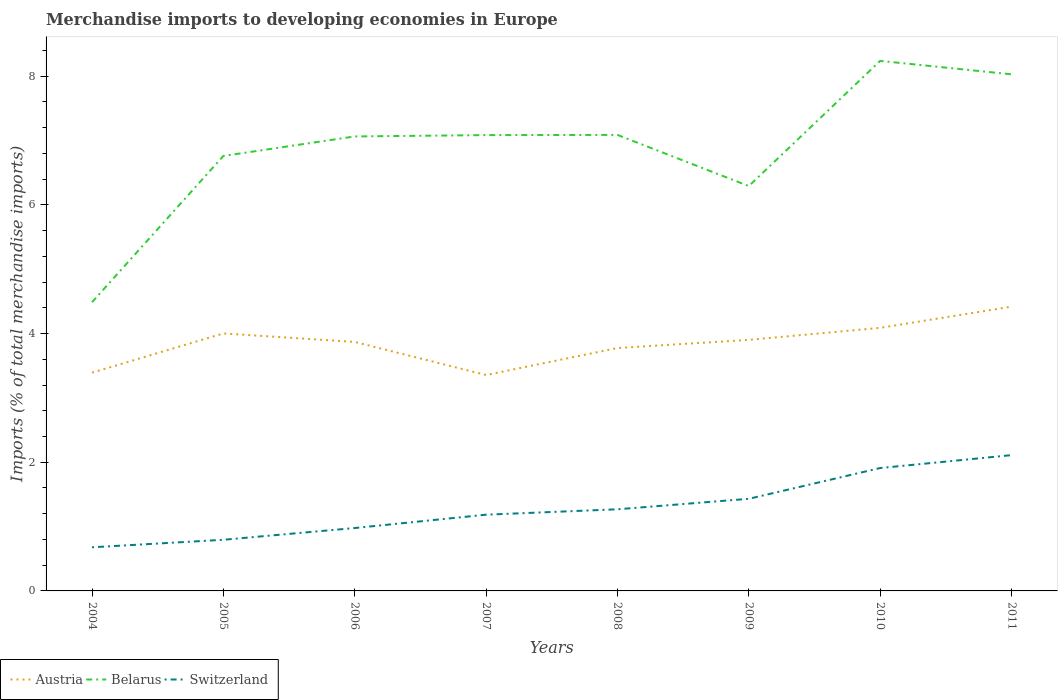Does the line corresponding to Switzerland intersect with the line corresponding to Austria?
Make the answer very short. No. Is the number of lines equal to the number of legend labels?
Your answer should be very brief. Yes. Across all years, what is the maximum percentage total merchandise imports in Austria?
Your response must be concise. 3.36. In which year was the percentage total merchandise imports in Austria maximum?
Offer a very short reply. 2007. What is the total percentage total merchandise imports in Austria in the graph?
Your response must be concise. -0.31. What is the difference between the highest and the second highest percentage total merchandise imports in Switzerland?
Offer a terse response. 1.43. Is the percentage total merchandise imports in Austria strictly greater than the percentage total merchandise imports in Switzerland over the years?
Your answer should be compact. No. How many lines are there?
Ensure brevity in your answer.  3. Does the graph contain grids?
Give a very brief answer. No. Where does the legend appear in the graph?
Your answer should be very brief. Bottom left. What is the title of the graph?
Provide a short and direct response. Merchandise imports to developing economies in Europe. What is the label or title of the X-axis?
Keep it short and to the point. Years. What is the label or title of the Y-axis?
Your answer should be very brief. Imports (% of total merchandise imports). What is the Imports (% of total merchandise imports) in Austria in 2004?
Ensure brevity in your answer.  3.39. What is the Imports (% of total merchandise imports) in Belarus in 2004?
Your answer should be compact. 4.49. What is the Imports (% of total merchandise imports) of Switzerland in 2004?
Ensure brevity in your answer.  0.68. What is the Imports (% of total merchandise imports) in Austria in 2005?
Offer a very short reply. 4. What is the Imports (% of total merchandise imports) of Belarus in 2005?
Your response must be concise. 6.76. What is the Imports (% of total merchandise imports) of Switzerland in 2005?
Your response must be concise. 0.79. What is the Imports (% of total merchandise imports) of Austria in 2006?
Make the answer very short. 3.87. What is the Imports (% of total merchandise imports) of Belarus in 2006?
Make the answer very short. 7.06. What is the Imports (% of total merchandise imports) in Switzerland in 2006?
Make the answer very short. 0.98. What is the Imports (% of total merchandise imports) in Austria in 2007?
Provide a succinct answer. 3.36. What is the Imports (% of total merchandise imports) in Belarus in 2007?
Provide a succinct answer. 7.08. What is the Imports (% of total merchandise imports) in Switzerland in 2007?
Provide a short and direct response. 1.18. What is the Imports (% of total merchandise imports) of Austria in 2008?
Provide a succinct answer. 3.77. What is the Imports (% of total merchandise imports) in Belarus in 2008?
Keep it short and to the point. 7.09. What is the Imports (% of total merchandise imports) of Switzerland in 2008?
Your answer should be compact. 1.27. What is the Imports (% of total merchandise imports) of Austria in 2009?
Ensure brevity in your answer.  3.9. What is the Imports (% of total merchandise imports) of Belarus in 2009?
Offer a very short reply. 6.29. What is the Imports (% of total merchandise imports) in Switzerland in 2009?
Provide a succinct answer. 1.43. What is the Imports (% of total merchandise imports) of Austria in 2010?
Offer a very short reply. 4.09. What is the Imports (% of total merchandise imports) of Belarus in 2010?
Offer a very short reply. 8.24. What is the Imports (% of total merchandise imports) of Switzerland in 2010?
Make the answer very short. 1.91. What is the Imports (% of total merchandise imports) in Austria in 2011?
Provide a succinct answer. 4.42. What is the Imports (% of total merchandise imports) of Belarus in 2011?
Your answer should be very brief. 8.03. What is the Imports (% of total merchandise imports) of Switzerland in 2011?
Provide a succinct answer. 2.11. Across all years, what is the maximum Imports (% of total merchandise imports) of Austria?
Ensure brevity in your answer.  4.42. Across all years, what is the maximum Imports (% of total merchandise imports) of Belarus?
Your answer should be very brief. 8.24. Across all years, what is the maximum Imports (% of total merchandise imports) in Switzerland?
Keep it short and to the point. 2.11. Across all years, what is the minimum Imports (% of total merchandise imports) in Austria?
Your response must be concise. 3.36. Across all years, what is the minimum Imports (% of total merchandise imports) in Belarus?
Provide a succinct answer. 4.49. Across all years, what is the minimum Imports (% of total merchandise imports) in Switzerland?
Keep it short and to the point. 0.68. What is the total Imports (% of total merchandise imports) of Austria in the graph?
Your answer should be very brief. 30.8. What is the total Imports (% of total merchandise imports) of Belarus in the graph?
Your answer should be very brief. 55.04. What is the total Imports (% of total merchandise imports) of Switzerland in the graph?
Offer a terse response. 10.36. What is the difference between the Imports (% of total merchandise imports) of Austria in 2004 and that in 2005?
Offer a terse response. -0.61. What is the difference between the Imports (% of total merchandise imports) in Belarus in 2004 and that in 2005?
Make the answer very short. -2.27. What is the difference between the Imports (% of total merchandise imports) in Switzerland in 2004 and that in 2005?
Ensure brevity in your answer.  -0.12. What is the difference between the Imports (% of total merchandise imports) of Austria in 2004 and that in 2006?
Your response must be concise. -0.48. What is the difference between the Imports (% of total merchandise imports) of Belarus in 2004 and that in 2006?
Offer a very short reply. -2.58. What is the difference between the Imports (% of total merchandise imports) of Switzerland in 2004 and that in 2006?
Offer a very short reply. -0.3. What is the difference between the Imports (% of total merchandise imports) in Austria in 2004 and that in 2007?
Your response must be concise. 0.04. What is the difference between the Imports (% of total merchandise imports) in Belarus in 2004 and that in 2007?
Offer a very short reply. -2.6. What is the difference between the Imports (% of total merchandise imports) in Switzerland in 2004 and that in 2007?
Your answer should be compact. -0.51. What is the difference between the Imports (% of total merchandise imports) of Austria in 2004 and that in 2008?
Provide a succinct answer. -0.38. What is the difference between the Imports (% of total merchandise imports) in Belarus in 2004 and that in 2008?
Ensure brevity in your answer.  -2.6. What is the difference between the Imports (% of total merchandise imports) of Switzerland in 2004 and that in 2008?
Provide a succinct answer. -0.59. What is the difference between the Imports (% of total merchandise imports) of Austria in 2004 and that in 2009?
Offer a terse response. -0.51. What is the difference between the Imports (% of total merchandise imports) in Belarus in 2004 and that in 2009?
Provide a succinct answer. -1.8. What is the difference between the Imports (% of total merchandise imports) of Switzerland in 2004 and that in 2009?
Provide a short and direct response. -0.75. What is the difference between the Imports (% of total merchandise imports) in Austria in 2004 and that in 2010?
Keep it short and to the point. -0.7. What is the difference between the Imports (% of total merchandise imports) in Belarus in 2004 and that in 2010?
Give a very brief answer. -3.75. What is the difference between the Imports (% of total merchandise imports) in Switzerland in 2004 and that in 2010?
Your answer should be compact. -1.23. What is the difference between the Imports (% of total merchandise imports) of Austria in 2004 and that in 2011?
Ensure brevity in your answer.  -1.03. What is the difference between the Imports (% of total merchandise imports) in Belarus in 2004 and that in 2011?
Your response must be concise. -3.54. What is the difference between the Imports (% of total merchandise imports) in Switzerland in 2004 and that in 2011?
Offer a very short reply. -1.43. What is the difference between the Imports (% of total merchandise imports) in Austria in 2005 and that in 2006?
Ensure brevity in your answer.  0.13. What is the difference between the Imports (% of total merchandise imports) in Belarus in 2005 and that in 2006?
Offer a very short reply. -0.3. What is the difference between the Imports (% of total merchandise imports) of Switzerland in 2005 and that in 2006?
Provide a succinct answer. -0.18. What is the difference between the Imports (% of total merchandise imports) in Austria in 2005 and that in 2007?
Ensure brevity in your answer.  0.65. What is the difference between the Imports (% of total merchandise imports) of Belarus in 2005 and that in 2007?
Provide a short and direct response. -0.32. What is the difference between the Imports (% of total merchandise imports) of Switzerland in 2005 and that in 2007?
Offer a terse response. -0.39. What is the difference between the Imports (% of total merchandise imports) in Austria in 2005 and that in 2008?
Ensure brevity in your answer.  0.23. What is the difference between the Imports (% of total merchandise imports) in Belarus in 2005 and that in 2008?
Ensure brevity in your answer.  -0.33. What is the difference between the Imports (% of total merchandise imports) in Switzerland in 2005 and that in 2008?
Keep it short and to the point. -0.47. What is the difference between the Imports (% of total merchandise imports) of Austria in 2005 and that in 2009?
Your response must be concise. 0.1. What is the difference between the Imports (% of total merchandise imports) in Belarus in 2005 and that in 2009?
Give a very brief answer. 0.47. What is the difference between the Imports (% of total merchandise imports) of Switzerland in 2005 and that in 2009?
Your response must be concise. -0.64. What is the difference between the Imports (% of total merchandise imports) in Austria in 2005 and that in 2010?
Provide a succinct answer. -0.09. What is the difference between the Imports (% of total merchandise imports) of Belarus in 2005 and that in 2010?
Ensure brevity in your answer.  -1.48. What is the difference between the Imports (% of total merchandise imports) of Switzerland in 2005 and that in 2010?
Provide a succinct answer. -1.11. What is the difference between the Imports (% of total merchandise imports) in Austria in 2005 and that in 2011?
Your response must be concise. -0.42. What is the difference between the Imports (% of total merchandise imports) of Belarus in 2005 and that in 2011?
Offer a terse response. -1.27. What is the difference between the Imports (% of total merchandise imports) of Switzerland in 2005 and that in 2011?
Provide a succinct answer. -1.32. What is the difference between the Imports (% of total merchandise imports) of Austria in 2006 and that in 2007?
Your answer should be very brief. 0.51. What is the difference between the Imports (% of total merchandise imports) in Belarus in 2006 and that in 2007?
Your answer should be very brief. -0.02. What is the difference between the Imports (% of total merchandise imports) of Switzerland in 2006 and that in 2007?
Your answer should be compact. -0.21. What is the difference between the Imports (% of total merchandise imports) in Austria in 2006 and that in 2008?
Your answer should be compact. 0.09. What is the difference between the Imports (% of total merchandise imports) of Belarus in 2006 and that in 2008?
Your answer should be very brief. -0.02. What is the difference between the Imports (% of total merchandise imports) of Switzerland in 2006 and that in 2008?
Your response must be concise. -0.29. What is the difference between the Imports (% of total merchandise imports) in Austria in 2006 and that in 2009?
Provide a short and direct response. -0.03. What is the difference between the Imports (% of total merchandise imports) in Belarus in 2006 and that in 2009?
Provide a succinct answer. 0.77. What is the difference between the Imports (% of total merchandise imports) in Switzerland in 2006 and that in 2009?
Offer a very short reply. -0.45. What is the difference between the Imports (% of total merchandise imports) of Austria in 2006 and that in 2010?
Give a very brief answer. -0.22. What is the difference between the Imports (% of total merchandise imports) in Belarus in 2006 and that in 2010?
Your answer should be compact. -1.17. What is the difference between the Imports (% of total merchandise imports) of Switzerland in 2006 and that in 2010?
Give a very brief answer. -0.93. What is the difference between the Imports (% of total merchandise imports) of Austria in 2006 and that in 2011?
Provide a short and direct response. -0.55. What is the difference between the Imports (% of total merchandise imports) of Belarus in 2006 and that in 2011?
Give a very brief answer. -0.97. What is the difference between the Imports (% of total merchandise imports) of Switzerland in 2006 and that in 2011?
Make the answer very short. -1.13. What is the difference between the Imports (% of total merchandise imports) of Austria in 2007 and that in 2008?
Offer a terse response. -0.42. What is the difference between the Imports (% of total merchandise imports) in Belarus in 2007 and that in 2008?
Keep it short and to the point. -0. What is the difference between the Imports (% of total merchandise imports) of Switzerland in 2007 and that in 2008?
Offer a terse response. -0.08. What is the difference between the Imports (% of total merchandise imports) in Austria in 2007 and that in 2009?
Your answer should be very brief. -0.55. What is the difference between the Imports (% of total merchandise imports) in Belarus in 2007 and that in 2009?
Provide a short and direct response. 0.79. What is the difference between the Imports (% of total merchandise imports) of Switzerland in 2007 and that in 2009?
Offer a very short reply. -0.25. What is the difference between the Imports (% of total merchandise imports) of Austria in 2007 and that in 2010?
Your answer should be compact. -0.73. What is the difference between the Imports (% of total merchandise imports) in Belarus in 2007 and that in 2010?
Offer a terse response. -1.15. What is the difference between the Imports (% of total merchandise imports) in Switzerland in 2007 and that in 2010?
Offer a very short reply. -0.72. What is the difference between the Imports (% of total merchandise imports) of Austria in 2007 and that in 2011?
Offer a very short reply. -1.06. What is the difference between the Imports (% of total merchandise imports) of Belarus in 2007 and that in 2011?
Your answer should be very brief. -0.94. What is the difference between the Imports (% of total merchandise imports) of Switzerland in 2007 and that in 2011?
Provide a short and direct response. -0.93. What is the difference between the Imports (% of total merchandise imports) of Austria in 2008 and that in 2009?
Keep it short and to the point. -0.13. What is the difference between the Imports (% of total merchandise imports) in Belarus in 2008 and that in 2009?
Offer a very short reply. 0.8. What is the difference between the Imports (% of total merchandise imports) of Switzerland in 2008 and that in 2009?
Provide a short and direct response. -0.16. What is the difference between the Imports (% of total merchandise imports) in Austria in 2008 and that in 2010?
Ensure brevity in your answer.  -0.31. What is the difference between the Imports (% of total merchandise imports) in Belarus in 2008 and that in 2010?
Offer a terse response. -1.15. What is the difference between the Imports (% of total merchandise imports) in Switzerland in 2008 and that in 2010?
Your response must be concise. -0.64. What is the difference between the Imports (% of total merchandise imports) in Austria in 2008 and that in 2011?
Provide a short and direct response. -0.64. What is the difference between the Imports (% of total merchandise imports) in Belarus in 2008 and that in 2011?
Provide a succinct answer. -0.94. What is the difference between the Imports (% of total merchandise imports) in Switzerland in 2008 and that in 2011?
Your answer should be compact. -0.84. What is the difference between the Imports (% of total merchandise imports) in Austria in 2009 and that in 2010?
Give a very brief answer. -0.19. What is the difference between the Imports (% of total merchandise imports) in Belarus in 2009 and that in 2010?
Your answer should be compact. -1.95. What is the difference between the Imports (% of total merchandise imports) of Switzerland in 2009 and that in 2010?
Offer a terse response. -0.48. What is the difference between the Imports (% of total merchandise imports) of Austria in 2009 and that in 2011?
Provide a succinct answer. -0.52. What is the difference between the Imports (% of total merchandise imports) of Belarus in 2009 and that in 2011?
Make the answer very short. -1.74. What is the difference between the Imports (% of total merchandise imports) of Switzerland in 2009 and that in 2011?
Make the answer very short. -0.68. What is the difference between the Imports (% of total merchandise imports) in Austria in 2010 and that in 2011?
Offer a very short reply. -0.33. What is the difference between the Imports (% of total merchandise imports) in Belarus in 2010 and that in 2011?
Provide a succinct answer. 0.21. What is the difference between the Imports (% of total merchandise imports) of Switzerland in 2010 and that in 2011?
Make the answer very short. -0.2. What is the difference between the Imports (% of total merchandise imports) in Austria in 2004 and the Imports (% of total merchandise imports) in Belarus in 2005?
Offer a terse response. -3.37. What is the difference between the Imports (% of total merchandise imports) in Austria in 2004 and the Imports (% of total merchandise imports) in Switzerland in 2005?
Offer a very short reply. 2.6. What is the difference between the Imports (% of total merchandise imports) of Belarus in 2004 and the Imports (% of total merchandise imports) of Switzerland in 2005?
Your response must be concise. 3.69. What is the difference between the Imports (% of total merchandise imports) in Austria in 2004 and the Imports (% of total merchandise imports) in Belarus in 2006?
Your answer should be very brief. -3.67. What is the difference between the Imports (% of total merchandise imports) of Austria in 2004 and the Imports (% of total merchandise imports) of Switzerland in 2006?
Your answer should be compact. 2.41. What is the difference between the Imports (% of total merchandise imports) of Belarus in 2004 and the Imports (% of total merchandise imports) of Switzerland in 2006?
Keep it short and to the point. 3.51. What is the difference between the Imports (% of total merchandise imports) in Austria in 2004 and the Imports (% of total merchandise imports) in Belarus in 2007?
Keep it short and to the point. -3.69. What is the difference between the Imports (% of total merchandise imports) of Austria in 2004 and the Imports (% of total merchandise imports) of Switzerland in 2007?
Make the answer very short. 2.21. What is the difference between the Imports (% of total merchandise imports) of Belarus in 2004 and the Imports (% of total merchandise imports) of Switzerland in 2007?
Keep it short and to the point. 3.3. What is the difference between the Imports (% of total merchandise imports) in Austria in 2004 and the Imports (% of total merchandise imports) in Belarus in 2008?
Provide a succinct answer. -3.69. What is the difference between the Imports (% of total merchandise imports) of Austria in 2004 and the Imports (% of total merchandise imports) of Switzerland in 2008?
Provide a short and direct response. 2.12. What is the difference between the Imports (% of total merchandise imports) of Belarus in 2004 and the Imports (% of total merchandise imports) of Switzerland in 2008?
Your response must be concise. 3.22. What is the difference between the Imports (% of total merchandise imports) in Austria in 2004 and the Imports (% of total merchandise imports) in Belarus in 2009?
Make the answer very short. -2.9. What is the difference between the Imports (% of total merchandise imports) in Austria in 2004 and the Imports (% of total merchandise imports) in Switzerland in 2009?
Your answer should be very brief. 1.96. What is the difference between the Imports (% of total merchandise imports) of Belarus in 2004 and the Imports (% of total merchandise imports) of Switzerland in 2009?
Keep it short and to the point. 3.05. What is the difference between the Imports (% of total merchandise imports) of Austria in 2004 and the Imports (% of total merchandise imports) of Belarus in 2010?
Your answer should be very brief. -4.85. What is the difference between the Imports (% of total merchandise imports) of Austria in 2004 and the Imports (% of total merchandise imports) of Switzerland in 2010?
Your response must be concise. 1.48. What is the difference between the Imports (% of total merchandise imports) in Belarus in 2004 and the Imports (% of total merchandise imports) in Switzerland in 2010?
Your answer should be very brief. 2.58. What is the difference between the Imports (% of total merchandise imports) in Austria in 2004 and the Imports (% of total merchandise imports) in Belarus in 2011?
Give a very brief answer. -4.64. What is the difference between the Imports (% of total merchandise imports) in Austria in 2004 and the Imports (% of total merchandise imports) in Switzerland in 2011?
Ensure brevity in your answer.  1.28. What is the difference between the Imports (% of total merchandise imports) of Belarus in 2004 and the Imports (% of total merchandise imports) of Switzerland in 2011?
Provide a succinct answer. 2.38. What is the difference between the Imports (% of total merchandise imports) in Austria in 2005 and the Imports (% of total merchandise imports) in Belarus in 2006?
Ensure brevity in your answer.  -3.06. What is the difference between the Imports (% of total merchandise imports) of Austria in 2005 and the Imports (% of total merchandise imports) of Switzerland in 2006?
Provide a succinct answer. 3.02. What is the difference between the Imports (% of total merchandise imports) in Belarus in 2005 and the Imports (% of total merchandise imports) in Switzerland in 2006?
Offer a terse response. 5.78. What is the difference between the Imports (% of total merchandise imports) of Austria in 2005 and the Imports (% of total merchandise imports) of Belarus in 2007?
Provide a succinct answer. -3.08. What is the difference between the Imports (% of total merchandise imports) of Austria in 2005 and the Imports (% of total merchandise imports) of Switzerland in 2007?
Your answer should be very brief. 2.82. What is the difference between the Imports (% of total merchandise imports) of Belarus in 2005 and the Imports (% of total merchandise imports) of Switzerland in 2007?
Make the answer very short. 5.58. What is the difference between the Imports (% of total merchandise imports) in Austria in 2005 and the Imports (% of total merchandise imports) in Belarus in 2008?
Ensure brevity in your answer.  -3.09. What is the difference between the Imports (% of total merchandise imports) in Austria in 2005 and the Imports (% of total merchandise imports) in Switzerland in 2008?
Your response must be concise. 2.73. What is the difference between the Imports (% of total merchandise imports) of Belarus in 2005 and the Imports (% of total merchandise imports) of Switzerland in 2008?
Ensure brevity in your answer.  5.49. What is the difference between the Imports (% of total merchandise imports) of Austria in 2005 and the Imports (% of total merchandise imports) of Belarus in 2009?
Give a very brief answer. -2.29. What is the difference between the Imports (% of total merchandise imports) in Austria in 2005 and the Imports (% of total merchandise imports) in Switzerland in 2009?
Make the answer very short. 2.57. What is the difference between the Imports (% of total merchandise imports) in Belarus in 2005 and the Imports (% of total merchandise imports) in Switzerland in 2009?
Give a very brief answer. 5.33. What is the difference between the Imports (% of total merchandise imports) of Austria in 2005 and the Imports (% of total merchandise imports) of Belarus in 2010?
Provide a succinct answer. -4.24. What is the difference between the Imports (% of total merchandise imports) of Austria in 2005 and the Imports (% of total merchandise imports) of Switzerland in 2010?
Give a very brief answer. 2.09. What is the difference between the Imports (% of total merchandise imports) of Belarus in 2005 and the Imports (% of total merchandise imports) of Switzerland in 2010?
Provide a short and direct response. 4.85. What is the difference between the Imports (% of total merchandise imports) in Austria in 2005 and the Imports (% of total merchandise imports) in Belarus in 2011?
Ensure brevity in your answer.  -4.03. What is the difference between the Imports (% of total merchandise imports) in Austria in 2005 and the Imports (% of total merchandise imports) in Switzerland in 2011?
Keep it short and to the point. 1.89. What is the difference between the Imports (% of total merchandise imports) of Belarus in 2005 and the Imports (% of total merchandise imports) of Switzerland in 2011?
Your answer should be compact. 4.65. What is the difference between the Imports (% of total merchandise imports) of Austria in 2006 and the Imports (% of total merchandise imports) of Belarus in 2007?
Your response must be concise. -3.21. What is the difference between the Imports (% of total merchandise imports) of Austria in 2006 and the Imports (% of total merchandise imports) of Switzerland in 2007?
Your answer should be very brief. 2.68. What is the difference between the Imports (% of total merchandise imports) of Belarus in 2006 and the Imports (% of total merchandise imports) of Switzerland in 2007?
Give a very brief answer. 5.88. What is the difference between the Imports (% of total merchandise imports) in Austria in 2006 and the Imports (% of total merchandise imports) in Belarus in 2008?
Your answer should be very brief. -3.22. What is the difference between the Imports (% of total merchandise imports) in Austria in 2006 and the Imports (% of total merchandise imports) in Switzerland in 2008?
Offer a very short reply. 2.6. What is the difference between the Imports (% of total merchandise imports) in Belarus in 2006 and the Imports (% of total merchandise imports) in Switzerland in 2008?
Your response must be concise. 5.79. What is the difference between the Imports (% of total merchandise imports) of Austria in 2006 and the Imports (% of total merchandise imports) of Belarus in 2009?
Provide a succinct answer. -2.42. What is the difference between the Imports (% of total merchandise imports) of Austria in 2006 and the Imports (% of total merchandise imports) of Switzerland in 2009?
Offer a terse response. 2.44. What is the difference between the Imports (% of total merchandise imports) of Belarus in 2006 and the Imports (% of total merchandise imports) of Switzerland in 2009?
Offer a very short reply. 5.63. What is the difference between the Imports (% of total merchandise imports) in Austria in 2006 and the Imports (% of total merchandise imports) in Belarus in 2010?
Your response must be concise. -4.37. What is the difference between the Imports (% of total merchandise imports) in Austria in 2006 and the Imports (% of total merchandise imports) in Switzerland in 2010?
Ensure brevity in your answer.  1.96. What is the difference between the Imports (% of total merchandise imports) in Belarus in 2006 and the Imports (% of total merchandise imports) in Switzerland in 2010?
Keep it short and to the point. 5.15. What is the difference between the Imports (% of total merchandise imports) in Austria in 2006 and the Imports (% of total merchandise imports) in Belarus in 2011?
Your answer should be very brief. -4.16. What is the difference between the Imports (% of total merchandise imports) in Austria in 2006 and the Imports (% of total merchandise imports) in Switzerland in 2011?
Give a very brief answer. 1.76. What is the difference between the Imports (% of total merchandise imports) in Belarus in 2006 and the Imports (% of total merchandise imports) in Switzerland in 2011?
Give a very brief answer. 4.95. What is the difference between the Imports (% of total merchandise imports) in Austria in 2007 and the Imports (% of total merchandise imports) in Belarus in 2008?
Give a very brief answer. -3.73. What is the difference between the Imports (% of total merchandise imports) of Austria in 2007 and the Imports (% of total merchandise imports) of Switzerland in 2008?
Keep it short and to the point. 2.09. What is the difference between the Imports (% of total merchandise imports) in Belarus in 2007 and the Imports (% of total merchandise imports) in Switzerland in 2008?
Provide a short and direct response. 5.82. What is the difference between the Imports (% of total merchandise imports) of Austria in 2007 and the Imports (% of total merchandise imports) of Belarus in 2009?
Keep it short and to the point. -2.94. What is the difference between the Imports (% of total merchandise imports) of Austria in 2007 and the Imports (% of total merchandise imports) of Switzerland in 2009?
Your answer should be compact. 1.92. What is the difference between the Imports (% of total merchandise imports) in Belarus in 2007 and the Imports (% of total merchandise imports) in Switzerland in 2009?
Your answer should be compact. 5.65. What is the difference between the Imports (% of total merchandise imports) in Austria in 2007 and the Imports (% of total merchandise imports) in Belarus in 2010?
Give a very brief answer. -4.88. What is the difference between the Imports (% of total merchandise imports) in Austria in 2007 and the Imports (% of total merchandise imports) in Switzerland in 2010?
Make the answer very short. 1.45. What is the difference between the Imports (% of total merchandise imports) in Belarus in 2007 and the Imports (% of total merchandise imports) in Switzerland in 2010?
Provide a short and direct response. 5.17. What is the difference between the Imports (% of total merchandise imports) in Austria in 2007 and the Imports (% of total merchandise imports) in Belarus in 2011?
Your answer should be compact. -4.67. What is the difference between the Imports (% of total merchandise imports) of Austria in 2007 and the Imports (% of total merchandise imports) of Switzerland in 2011?
Your answer should be very brief. 1.25. What is the difference between the Imports (% of total merchandise imports) in Belarus in 2007 and the Imports (% of total merchandise imports) in Switzerland in 2011?
Your response must be concise. 4.97. What is the difference between the Imports (% of total merchandise imports) of Austria in 2008 and the Imports (% of total merchandise imports) of Belarus in 2009?
Your response must be concise. -2.52. What is the difference between the Imports (% of total merchandise imports) in Austria in 2008 and the Imports (% of total merchandise imports) in Switzerland in 2009?
Your response must be concise. 2.34. What is the difference between the Imports (% of total merchandise imports) in Belarus in 2008 and the Imports (% of total merchandise imports) in Switzerland in 2009?
Your answer should be compact. 5.66. What is the difference between the Imports (% of total merchandise imports) in Austria in 2008 and the Imports (% of total merchandise imports) in Belarus in 2010?
Ensure brevity in your answer.  -4.46. What is the difference between the Imports (% of total merchandise imports) of Austria in 2008 and the Imports (% of total merchandise imports) of Switzerland in 2010?
Your answer should be compact. 1.86. What is the difference between the Imports (% of total merchandise imports) in Belarus in 2008 and the Imports (% of total merchandise imports) in Switzerland in 2010?
Make the answer very short. 5.18. What is the difference between the Imports (% of total merchandise imports) of Austria in 2008 and the Imports (% of total merchandise imports) of Belarus in 2011?
Make the answer very short. -4.25. What is the difference between the Imports (% of total merchandise imports) of Austria in 2008 and the Imports (% of total merchandise imports) of Switzerland in 2011?
Keep it short and to the point. 1.66. What is the difference between the Imports (% of total merchandise imports) of Belarus in 2008 and the Imports (% of total merchandise imports) of Switzerland in 2011?
Your answer should be very brief. 4.98. What is the difference between the Imports (% of total merchandise imports) of Austria in 2009 and the Imports (% of total merchandise imports) of Belarus in 2010?
Your answer should be compact. -4.34. What is the difference between the Imports (% of total merchandise imports) in Austria in 2009 and the Imports (% of total merchandise imports) in Switzerland in 2010?
Provide a short and direct response. 1.99. What is the difference between the Imports (% of total merchandise imports) of Belarus in 2009 and the Imports (% of total merchandise imports) of Switzerland in 2010?
Offer a terse response. 4.38. What is the difference between the Imports (% of total merchandise imports) of Austria in 2009 and the Imports (% of total merchandise imports) of Belarus in 2011?
Ensure brevity in your answer.  -4.13. What is the difference between the Imports (% of total merchandise imports) in Austria in 2009 and the Imports (% of total merchandise imports) in Switzerland in 2011?
Offer a very short reply. 1.79. What is the difference between the Imports (% of total merchandise imports) of Belarus in 2009 and the Imports (% of total merchandise imports) of Switzerland in 2011?
Ensure brevity in your answer.  4.18. What is the difference between the Imports (% of total merchandise imports) of Austria in 2010 and the Imports (% of total merchandise imports) of Belarus in 2011?
Give a very brief answer. -3.94. What is the difference between the Imports (% of total merchandise imports) of Austria in 2010 and the Imports (% of total merchandise imports) of Switzerland in 2011?
Ensure brevity in your answer.  1.98. What is the difference between the Imports (% of total merchandise imports) in Belarus in 2010 and the Imports (% of total merchandise imports) in Switzerland in 2011?
Your response must be concise. 6.13. What is the average Imports (% of total merchandise imports) of Austria per year?
Provide a succinct answer. 3.85. What is the average Imports (% of total merchandise imports) in Belarus per year?
Offer a very short reply. 6.88. What is the average Imports (% of total merchandise imports) in Switzerland per year?
Provide a short and direct response. 1.29. In the year 2004, what is the difference between the Imports (% of total merchandise imports) of Austria and Imports (% of total merchandise imports) of Belarus?
Give a very brief answer. -1.09. In the year 2004, what is the difference between the Imports (% of total merchandise imports) of Austria and Imports (% of total merchandise imports) of Switzerland?
Offer a very short reply. 2.71. In the year 2004, what is the difference between the Imports (% of total merchandise imports) in Belarus and Imports (% of total merchandise imports) in Switzerland?
Offer a very short reply. 3.81. In the year 2005, what is the difference between the Imports (% of total merchandise imports) of Austria and Imports (% of total merchandise imports) of Belarus?
Provide a succinct answer. -2.76. In the year 2005, what is the difference between the Imports (% of total merchandise imports) of Austria and Imports (% of total merchandise imports) of Switzerland?
Give a very brief answer. 3.21. In the year 2005, what is the difference between the Imports (% of total merchandise imports) in Belarus and Imports (% of total merchandise imports) in Switzerland?
Your answer should be very brief. 5.97. In the year 2006, what is the difference between the Imports (% of total merchandise imports) in Austria and Imports (% of total merchandise imports) in Belarus?
Your response must be concise. -3.19. In the year 2006, what is the difference between the Imports (% of total merchandise imports) of Austria and Imports (% of total merchandise imports) of Switzerland?
Give a very brief answer. 2.89. In the year 2006, what is the difference between the Imports (% of total merchandise imports) in Belarus and Imports (% of total merchandise imports) in Switzerland?
Make the answer very short. 6.09. In the year 2007, what is the difference between the Imports (% of total merchandise imports) in Austria and Imports (% of total merchandise imports) in Belarus?
Provide a succinct answer. -3.73. In the year 2007, what is the difference between the Imports (% of total merchandise imports) in Austria and Imports (% of total merchandise imports) in Switzerland?
Offer a very short reply. 2.17. In the year 2007, what is the difference between the Imports (% of total merchandise imports) of Belarus and Imports (% of total merchandise imports) of Switzerland?
Your response must be concise. 5.9. In the year 2008, what is the difference between the Imports (% of total merchandise imports) of Austria and Imports (% of total merchandise imports) of Belarus?
Your answer should be very brief. -3.31. In the year 2008, what is the difference between the Imports (% of total merchandise imports) of Austria and Imports (% of total merchandise imports) of Switzerland?
Offer a terse response. 2.51. In the year 2008, what is the difference between the Imports (% of total merchandise imports) in Belarus and Imports (% of total merchandise imports) in Switzerland?
Your answer should be very brief. 5.82. In the year 2009, what is the difference between the Imports (% of total merchandise imports) in Austria and Imports (% of total merchandise imports) in Belarus?
Your answer should be compact. -2.39. In the year 2009, what is the difference between the Imports (% of total merchandise imports) in Austria and Imports (% of total merchandise imports) in Switzerland?
Keep it short and to the point. 2.47. In the year 2009, what is the difference between the Imports (% of total merchandise imports) in Belarus and Imports (% of total merchandise imports) in Switzerland?
Provide a succinct answer. 4.86. In the year 2010, what is the difference between the Imports (% of total merchandise imports) of Austria and Imports (% of total merchandise imports) of Belarus?
Give a very brief answer. -4.15. In the year 2010, what is the difference between the Imports (% of total merchandise imports) in Austria and Imports (% of total merchandise imports) in Switzerland?
Keep it short and to the point. 2.18. In the year 2010, what is the difference between the Imports (% of total merchandise imports) in Belarus and Imports (% of total merchandise imports) in Switzerland?
Your response must be concise. 6.33. In the year 2011, what is the difference between the Imports (% of total merchandise imports) of Austria and Imports (% of total merchandise imports) of Belarus?
Keep it short and to the point. -3.61. In the year 2011, what is the difference between the Imports (% of total merchandise imports) of Austria and Imports (% of total merchandise imports) of Switzerland?
Provide a succinct answer. 2.31. In the year 2011, what is the difference between the Imports (% of total merchandise imports) in Belarus and Imports (% of total merchandise imports) in Switzerland?
Your response must be concise. 5.92. What is the ratio of the Imports (% of total merchandise imports) of Austria in 2004 to that in 2005?
Your answer should be compact. 0.85. What is the ratio of the Imports (% of total merchandise imports) in Belarus in 2004 to that in 2005?
Ensure brevity in your answer.  0.66. What is the ratio of the Imports (% of total merchandise imports) of Switzerland in 2004 to that in 2005?
Ensure brevity in your answer.  0.85. What is the ratio of the Imports (% of total merchandise imports) of Austria in 2004 to that in 2006?
Your answer should be compact. 0.88. What is the ratio of the Imports (% of total merchandise imports) of Belarus in 2004 to that in 2006?
Provide a short and direct response. 0.64. What is the ratio of the Imports (% of total merchandise imports) of Switzerland in 2004 to that in 2006?
Offer a terse response. 0.69. What is the ratio of the Imports (% of total merchandise imports) of Austria in 2004 to that in 2007?
Offer a very short reply. 1.01. What is the ratio of the Imports (% of total merchandise imports) of Belarus in 2004 to that in 2007?
Provide a short and direct response. 0.63. What is the ratio of the Imports (% of total merchandise imports) of Switzerland in 2004 to that in 2007?
Keep it short and to the point. 0.57. What is the ratio of the Imports (% of total merchandise imports) in Austria in 2004 to that in 2008?
Provide a short and direct response. 0.9. What is the ratio of the Imports (% of total merchandise imports) in Belarus in 2004 to that in 2008?
Offer a very short reply. 0.63. What is the ratio of the Imports (% of total merchandise imports) in Switzerland in 2004 to that in 2008?
Keep it short and to the point. 0.53. What is the ratio of the Imports (% of total merchandise imports) in Austria in 2004 to that in 2009?
Give a very brief answer. 0.87. What is the ratio of the Imports (% of total merchandise imports) of Belarus in 2004 to that in 2009?
Your answer should be very brief. 0.71. What is the ratio of the Imports (% of total merchandise imports) in Switzerland in 2004 to that in 2009?
Provide a short and direct response. 0.47. What is the ratio of the Imports (% of total merchandise imports) of Austria in 2004 to that in 2010?
Give a very brief answer. 0.83. What is the ratio of the Imports (% of total merchandise imports) of Belarus in 2004 to that in 2010?
Ensure brevity in your answer.  0.54. What is the ratio of the Imports (% of total merchandise imports) of Switzerland in 2004 to that in 2010?
Ensure brevity in your answer.  0.35. What is the ratio of the Imports (% of total merchandise imports) of Austria in 2004 to that in 2011?
Offer a very short reply. 0.77. What is the ratio of the Imports (% of total merchandise imports) in Belarus in 2004 to that in 2011?
Make the answer very short. 0.56. What is the ratio of the Imports (% of total merchandise imports) in Switzerland in 2004 to that in 2011?
Keep it short and to the point. 0.32. What is the ratio of the Imports (% of total merchandise imports) in Austria in 2005 to that in 2006?
Offer a terse response. 1.03. What is the ratio of the Imports (% of total merchandise imports) in Belarus in 2005 to that in 2006?
Provide a short and direct response. 0.96. What is the ratio of the Imports (% of total merchandise imports) of Switzerland in 2005 to that in 2006?
Your answer should be very brief. 0.81. What is the ratio of the Imports (% of total merchandise imports) of Austria in 2005 to that in 2007?
Your response must be concise. 1.19. What is the ratio of the Imports (% of total merchandise imports) of Belarus in 2005 to that in 2007?
Your answer should be very brief. 0.95. What is the ratio of the Imports (% of total merchandise imports) in Switzerland in 2005 to that in 2007?
Provide a short and direct response. 0.67. What is the ratio of the Imports (% of total merchandise imports) of Austria in 2005 to that in 2008?
Ensure brevity in your answer.  1.06. What is the ratio of the Imports (% of total merchandise imports) in Belarus in 2005 to that in 2008?
Ensure brevity in your answer.  0.95. What is the ratio of the Imports (% of total merchandise imports) in Switzerland in 2005 to that in 2008?
Your answer should be compact. 0.63. What is the ratio of the Imports (% of total merchandise imports) of Austria in 2005 to that in 2009?
Your response must be concise. 1.03. What is the ratio of the Imports (% of total merchandise imports) of Belarus in 2005 to that in 2009?
Give a very brief answer. 1.07. What is the ratio of the Imports (% of total merchandise imports) of Switzerland in 2005 to that in 2009?
Your response must be concise. 0.56. What is the ratio of the Imports (% of total merchandise imports) in Austria in 2005 to that in 2010?
Ensure brevity in your answer.  0.98. What is the ratio of the Imports (% of total merchandise imports) in Belarus in 2005 to that in 2010?
Make the answer very short. 0.82. What is the ratio of the Imports (% of total merchandise imports) in Switzerland in 2005 to that in 2010?
Give a very brief answer. 0.42. What is the ratio of the Imports (% of total merchandise imports) in Austria in 2005 to that in 2011?
Your response must be concise. 0.91. What is the ratio of the Imports (% of total merchandise imports) in Belarus in 2005 to that in 2011?
Your response must be concise. 0.84. What is the ratio of the Imports (% of total merchandise imports) of Switzerland in 2005 to that in 2011?
Give a very brief answer. 0.38. What is the ratio of the Imports (% of total merchandise imports) in Austria in 2006 to that in 2007?
Keep it short and to the point. 1.15. What is the ratio of the Imports (% of total merchandise imports) in Switzerland in 2006 to that in 2007?
Your answer should be very brief. 0.82. What is the ratio of the Imports (% of total merchandise imports) in Austria in 2006 to that in 2008?
Make the answer very short. 1.03. What is the ratio of the Imports (% of total merchandise imports) in Switzerland in 2006 to that in 2008?
Offer a terse response. 0.77. What is the ratio of the Imports (% of total merchandise imports) of Austria in 2006 to that in 2009?
Give a very brief answer. 0.99. What is the ratio of the Imports (% of total merchandise imports) in Belarus in 2006 to that in 2009?
Provide a succinct answer. 1.12. What is the ratio of the Imports (% of total merchandise imports) in Switzerland in 2006 to that in 2009?
Offer a very short reply. 0.68. What is the ratio of the Imports (% of total merchandise imports) of Austria in 2006 to that in 2010?
Offer a terse response. 0.95. What is the ratio of the Imports (% of total merchandise imports) of Belarus in 2006 to that in 2010?
Offer a terse response. 0.86. What is the ratio of the Imports (% of total merchandise imports) in Switzerland in 2006 to that in 2010?
Give a very brief answer. 0.51. What is the ratio of the Imports (% of total merchandise imports) of Austria in 2006 to that in 2011?
Provide a succinct answer. 0.88. What is the ratio of the Imports (% of total merchandise imports) in Belarus in 2006 to that in 2011?
Offer a terse response. 0.88. What is the ratio of the Imports (% of total merchandise imports) in Switzerland in 2006 to that in 2011?
Keep it short and to the point. 0.46. What is the ratio of the Imports (% of total merchandise imports) of Switzerland in 2007 to that in 2008?
Give a very brief answer. 0.93. What is the ratio of the Imports (% of total merchandise imports) in Austria in 2007 to that in 2009?
Provide a short and direct response. 0.86. What is the ratio of the Imports (% of total merchandise imports) in Belarus in 2007 to that in 2009?
Your answer should be very brief. 1.13. What is the ratio of the Imports (% of total merchandise imports) of Switzerland in 2007 to that in 2009?
Give a very brief answer. 0.83. What is the ratio of the Imports (% of total merchandise imports) in Austria in 2007 to that in 2010?
Give a very brief answer. 0.82. What is the ratio of the Imports (% of total merchandise imports) in Belarus in 2007 to that in 2010?
Give a very brief answer. 0.86. What is the ratio of the Imports (% of total merchandise imports) of Switzerland in 2007 to that in 2010?
Give a very brief answer. 0.62. What is the ratio of the Imports (% of total merchandise imports) in Austria in 2007 to that in 2011?
Keep it short and to the point. 0.76. What is the ratio of the Imports (% of total merchandise imports) in Belarus in 2007 to that in 2011?
Your response must be concise. 0.88. What is the ratio of the Imports (% of total merchandise imports) of Switzerland in 2007 to that in 2011?
Ensure brevity in your answer.  0.56. What is the ratio of the Imports (% of total merchandise imports) of Austria in 2008 to that in 2009?
Provide a succinct answer. 0.97. What is the ratio of the Imports (% of total merchandise imports) in Belarus in 2008 to that in 2009?
Offer a terse response. 1.13. What is the ratio of the Imports (% of total merchandise imports) in Switzerland in 2008 to that in 2009?
Give a very brief answer. 0.89. What is the ratio of the Imports (% of total merchandise imports) in Austria in 2008 to that in 2010?
Offer a very short reply. 0.92. What is the ratio of the Imports (% of total merchandise imports) of Belarus in 2008 to that in 2010?
Provide a short and direct response. 0.86. What is the ratio of the Imports (% of total merchandise imports) of Switzerland in 2008 to that in 2010?
Provide a short and direct response. 0.66. What is the ratio of the Imports (% of total merchandise imports) in Austria in 2008 to that in 2011?
Provide a succinct answer. 0.85. What is the ratio of the Imports (% of total merchandise imports) of Belarus in 2008 to that in 2011?
Your response must be concise. 0.88. What is the ratio of the Imports (% of total merchandise imports) in Switzerland in 2008 to that in 2011?
Your answer should be compact. 0.6. What is the ratio of the Imports (% of total merchandise imports) in Austria in 2009 to that in 2010?
Offer a very short reply. 0.95. What is the ratio of the Imports (% of total merchandise imports) in Belarus in 2009 to that in 2010?
Your answer should be very brief. 0.76. What is the ratio of the Imports (% of total merchandise imports) of Switzerland in 2009 to that in 2010?
Provide a succinct answer. 0.75. What is the ratio of the Imports (% of total merchandise imports) of Austria in 2009 to that in 2011?
Offer a very short reply. 0.88. What is the ratio of the Imports (% of total merchandise imports) in Belarus in 2009 to that in 2011?
Provide a succinct answer. 0.78. What is the ratio of the Imports (% of total merchandise imports) in Switzerland in 2009 to that in 2011?
Your answer should be compact. 0.68. What is the ratio of the Imports (% of total merchandise imports) of Austria in 2010 to that in 2011?
Provide a succinct answer. 0.93. What is the ratio of the Imports (% of total merchandise imports) in Switzerland in 2010 to that in 2011?
Your answer should be very brief. 0.91. What is the difference between the highest and the second highest Imports (% of total merchandise imports) in Austria?
Your answer should be very brief. 0.33. What is the difference between the highest and the second highest Imports (% of total merchandise imports) of Belarus?
Offer a very short reply. 0.21. What is the difference between the highest and the second highest Imports (% of total merchandise imports) in Switzerland?
Your answer should be compact. 0.2. What is the difference between the highest and the lowest Imports (% of total merchandise imports) in Belarus?
Provide a short and direct response. 3.75. What is the difference between the highest and the lowest Imports (% of total merchandise imports) in Switzerland?
Offer a very short reply. 1.43. 